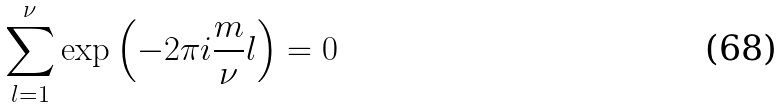<formula> <loc_0><loc_0><loc_500><loc_500>\sum _ { l = 1 } ^ { \nu } \exp \left ( - 2 \pi i \frac { m } { \nu } l \right ) = 0</formula> 